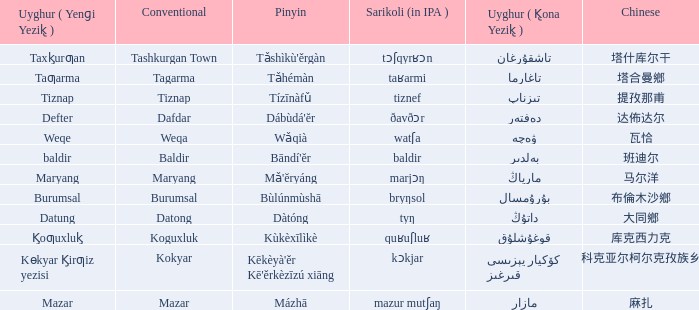Name the pinyin for  kɵkyar k̡irƣiz yezisi Kēkèyà'ěr Kē'ěrkèzīzú xiāng. 